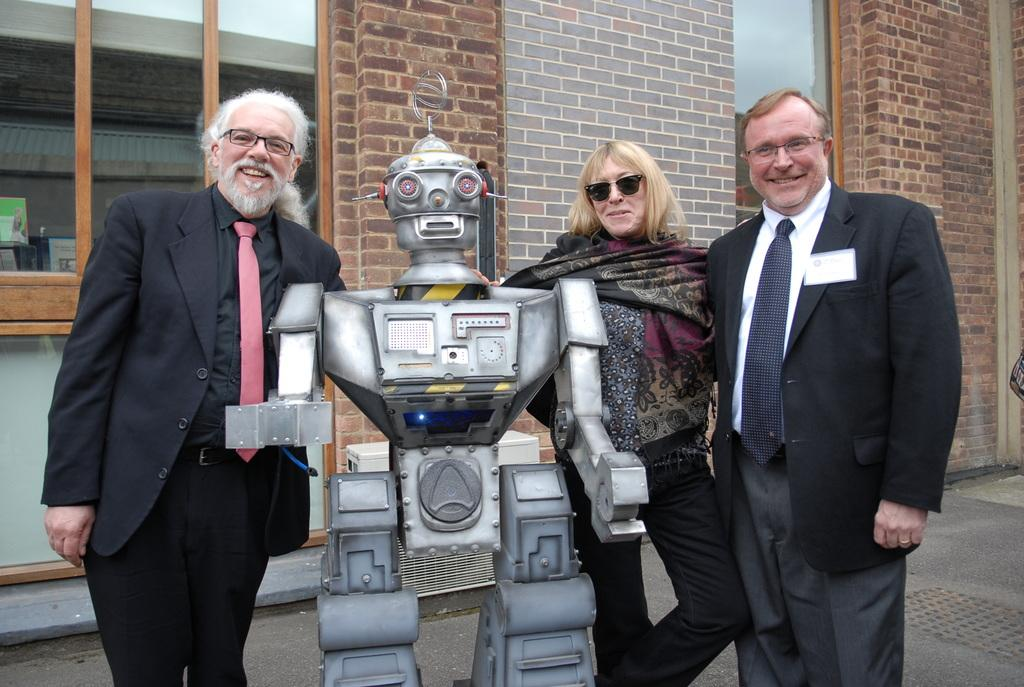What can be seen in the image? There are people standing in the image, along with a robot. What is the location of the robot in the image? The robot is in the image with the people. What is visible in the background of the image? There is a building in the background of the image. How are the people in the image feeling? The people in the image have smiles on their faces, indicating they are happy or enjoying themselves. How many crates are stacked next to the robot in the image? There are no crates present in the image; it only features people, a robot, and a building in the background. 